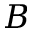Convert formula to latex. <formula><loc_0><loc_0><loc_500><loc_500>B</formula> 